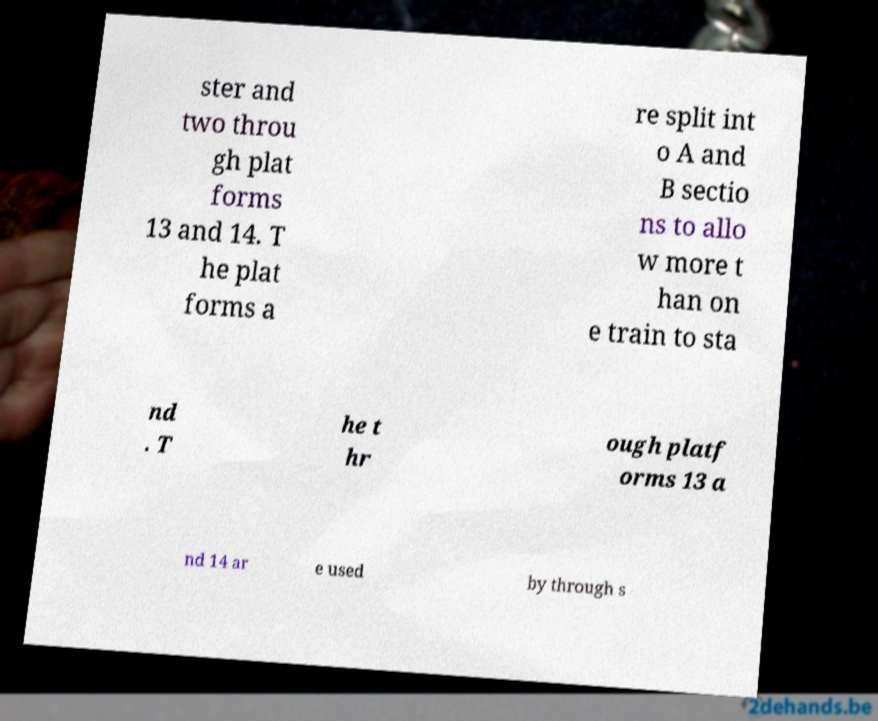Can you accurately transcribe the text from the provided image for me? ster and two throu gh plat forms 13 and 14. T he plat forms a re split int o A and B sectio ns to allo w more t han on e train to sta nd . T he t hr ough platf orms 13 a nd 14 ar e used by through s 